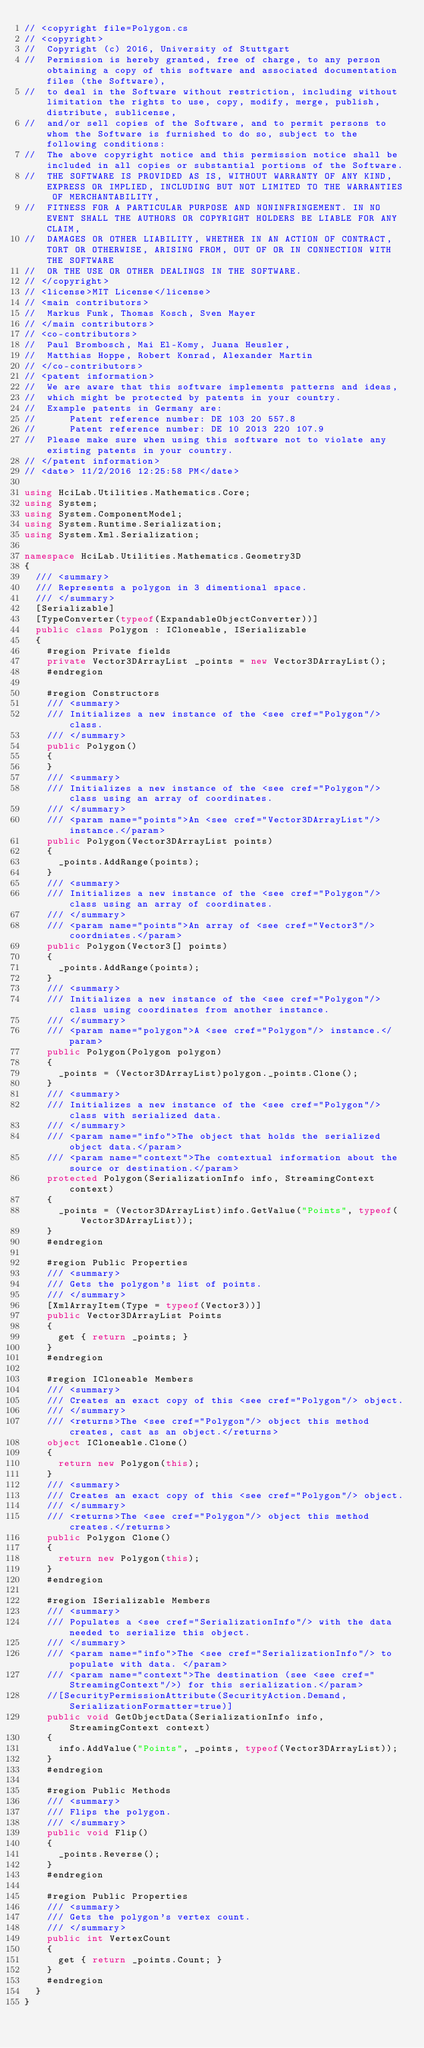Convert code to text. <code><loc_0><loc_0><loc_500><loc_500><_C#_>// <copyright file=Polygon.cs
// <copyright>
//  Copyright (c) 2016, University of Stuttgart
//  Permission is hereby granted, free of charge, to any person obtaining a copy of this software and associated documentation files (the Software),
//  to deal in the Software without restriction, including without limitation the rights to use, copy, modify, merge, publish, distribute, sublicense,
//  and/or sell copies of the Software, and to permit persons to whom the Software is furnished to do so, subject to the following conditions:
//  The above copyright notice and this permission notice shall be included in all copies or substantial portions of the Software.
//  THE SOFTWARE IS PROVIDED AS IS, WITHOUT WARRANTY OF ANY KIND, EXPRESS OR IMPLIED, INCLUDING BUT NOT LIMITED TO THE WARRANTIES OF MERCHANTABILITY,
//  FITNESS FOR A PARTICULAR PURPOSE AND NONINFRINGEMENT. IN NO EVENT SHALL THE AUTHORS OR COPYRIGHT HOLDERS BE LIABLE FOR ANY CLAIM,
//  DAMAGES OR OTHER LIABILITY, WHETHER IN AN ACTION OF CONTRACT, TORT OR OTHERWISE, ARISING FROM, OUT OF OR IN CONNECTION WITH THE SOFTWARE
//  OR THE USE OR OTHER DEALINGS IN THE SOFTWARE.
// </copyright>
// <license>MIT License</license>
// <main contributors>
//  Markus Funk, Thomas Kosch, Sven Mayer
// </main contributors>
// <co-contributors>
//  Paul Brombosch, Mai El-Komy, Juana Heusler, 
//  Matthias Hoppe, Robert Konrad, Alexander Martin
// </co-contributors>
// <patent information>
//  We are aware that this software implements patterns and ideas,
//  which might be protected by patents in your country.
//  Example patents in Germany are:
//      Patent reference number: DE 103 20 557.8
//      Patent reference number: DE 10 2013 220 107.9
//  Please make sure when using this software not to violate any existing patents in your country.
// </patent information>
// <date> 11/2/2016 12:25:58 PM</date>

using HciLab.Utilities.Mathematics.Core;
using System;
using System.ComponentModel;
using System.Runtime.Serialization;
using System.Xml.Serialization;

namespace HciLab.Utilities.Mathematics.Geometry3D
{
	/// <summary>
	/// Represents a polygon in 3 dimentional space.
	/// </summary>
	[Serializable]
	[TypeConverter(typeof(ExpandableObjectConverter))]
	public class Polygon : ICloneable, ISerializable
	{
		#region Private fields
		private Vector3DArrayList _points = new Vector3DArrayList();
		#endregion

		#region Constructors
		/// <summary>
		/// Initializes a new instance of the <see cref="Polygon"/> class.
		/// </summary>
		public Polygon()
		{
		}
		/// <summary>
		/// Initializes a new instance of the <see cref="Polygon"/> class using an array of coordinates.
		/// </summary>
		/// <param name="points">An <see cref="Vector3DArrayList"/> instance.</param>
		public Polygon(Vector3DArrayList points)
		{
			_points.AddRange(points);
		}
		/// <summary>
		/// Initializes a new instance of the <see cref="Polygon"/> class using an array of coordinates.
		/// </summary>
		/// <param name="points">An array of <see cref="Vector3"/> coordniates.</param>
		public Polygon(Vector3[] points)
		{
			_points.AddRange(points);
		}
		/// <summary>
		/// Initializes a new instance of the <see cref="Polygon"/> class using coordinates from another instance.
		/// </summary>
		/// <param name="polygon">A <see cref="Polygon"/> instance.</param>
		public Polygon(Polygon polygon)
		{
			_points = (Vector3DArrayList)polygon._points.Clone();
		}
		/// <summary>
		/// Initializes a new instance of the <see cref="Polygon"/> class with serialized data.
		/// </summary>
		/// <param name="info">The object that holds the serialized object data.</param>
		/// <param name="context">The contextual information about the source or destination.</param>
		protected Polygon(SerializationInfo info, StreamingContext context)
		{
			_points = (Vector3DArrayList)info.GetValue("Points", typeof(Vector3DArrayList));
		}
		#endregion

		#region Public Properties
		/// <summary>
		/// Gets the polygon's list of points.
		/// </summary>
		[XmlArrayItem(Type = typeof(Vector3))]
		public Vector3DArrayList Points
		{
			get { return _points; }
		}
		#endregion

		#region ICloneable Members
		/// <summary>
		/// Creates an exact copy of this <see cref="Polygon"/> object.
		/// </summary>
		/// <returns>The <see cref="Polygon"/> object this method creates, cast as an object.</returns>
		object ICloneable.Clone()
		{
			return new Polygon(this);
		}
		/// <summary>
		/// Creates an exact copy of this <see cref="Polygon"/> object.
		/// </summary>
		/// <returns>The <see cref="Polygon"/> object this method creates.</returns>
		public Polygon Clone()
		{
			return new Polygon(this);
		}
		#endregion

		#region ISerializable Members
		/// <summary>
		/// Populates a <see cref="SerializationInfo"/> with the data needed to serialize this object.
		/// </summary>
		/// <param name="info">The <see cref="SerializationInfo"/> to populate with data. </param>
		/// <param name="context">The destination (see <see cref="StreamingContext"/>) for this serialization.</param>
		//[SecurityPermissionAttribute(SecurityAction.Demand, SerializationFormatter=true)]
		public void GetObjectData(SerializationInfo info, StreamingContext context)
		{
			info.AddValue("Points", _points, typeof(Vector3DArrayList));
		}
		#endregion

		#region Public Methods
		/// <summary>
		/// Flips the polygon.
		/// </summary>
		public void Flip()
		{
			_points.Reverse();
		}
		#endregion

		#region Public Properties
		/// <summary>
		/// Gets the polygon's vertex count.
		/// </summary>
		public int VertexCount
		{
			get { return _points.Count; }
		}
		#endregion
	}
}
</code> 